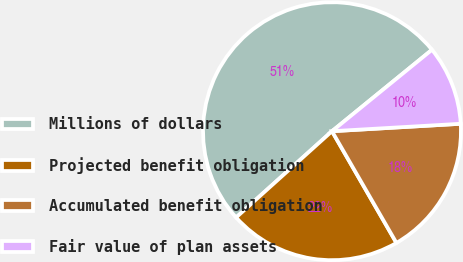Convert chart. <chart><loc_0><loc_0><loc_500><loc_500><pie_chart><fcel>Millions of dollars<fcel>Projected benefit obligation<fcel>Accumulated benefit obligation<fcel>Fair value of plan assets<nl><fcel>50.78%<fcel>21.67%<fcel>17.59%<fcel>9.96%<nl></chart> 